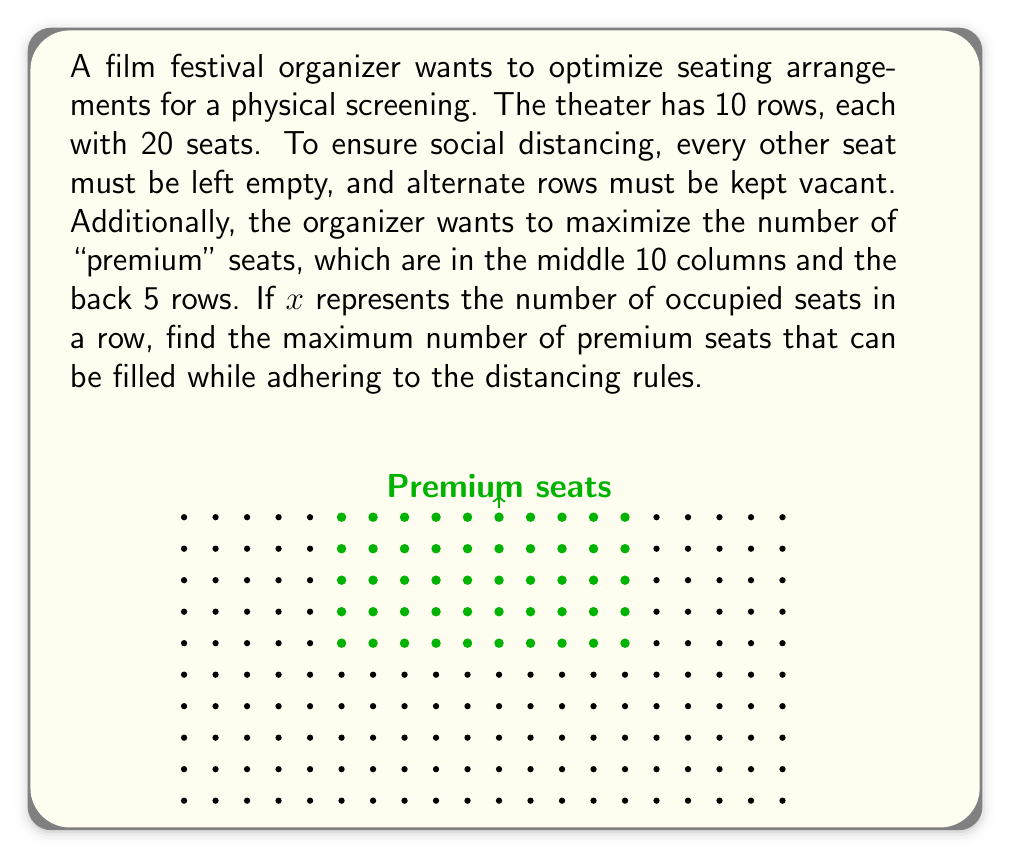Could you help me with this problem? Let's approach this step-by-step:

1) First, we need to determine how many rows can be occupied:
   - Every other row must be vacant
   - So, out of 10 rows, we can use 5 rows

2) Now, let's consider the seating in each row:
   - There are 20 seats per row
   - Every other seat must be empty
   - This means we can use at most 10 seats per row

3) The optimization problem can be formulated as:
   $$\max(x) \text{ subject to } x \leq 10$$

4) The premium seats are in the middle 10 columns and back 5 rows:
   - This means only the back 3 occupied rows are considered premium
   - In these rows, only the middle 10 seats are premium

5) In each of these 3 rows, the maximum number of premium seats is:
   $$\min(x, 5)$$
   This is because even if $x > 5$, we can only fit 5 premium seats in the middle 10 columns.

6) Therefore, the total number of premium seats is:
   $$3 \cdot \min(x, 5)$$

7) To maximize this, we want $x = 5$

8) Thus, the maximum number of premium seats is:
   $$3 \cdot 5 = 15$$
Answer: 15 premium seats 